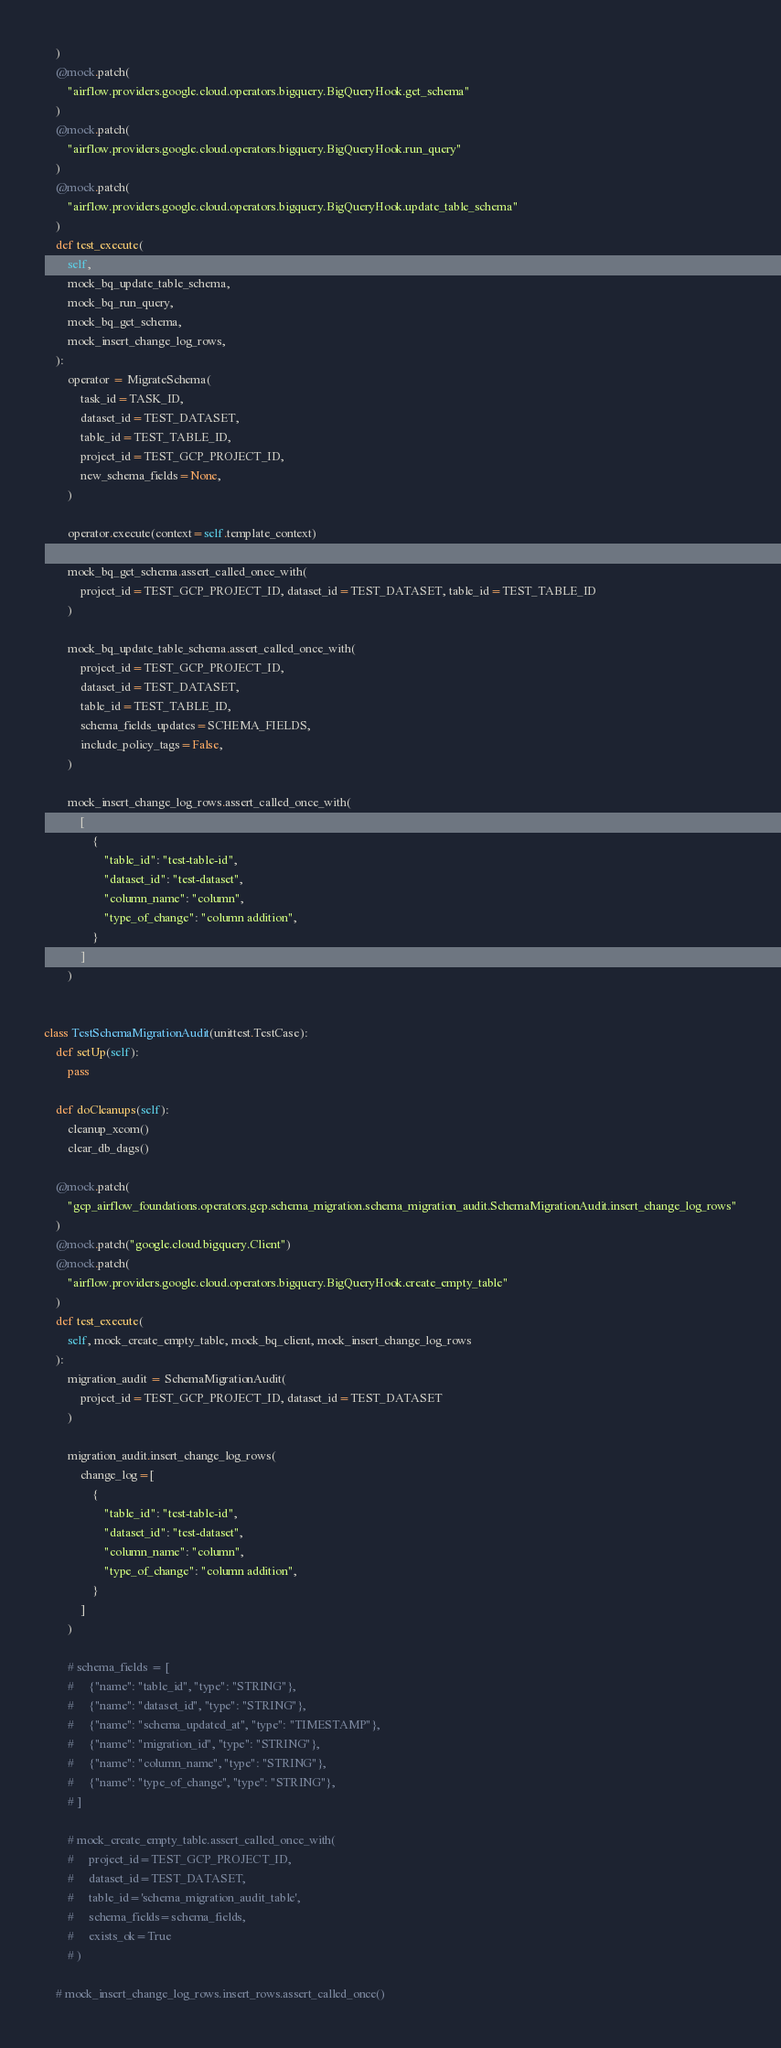<code> <loc_0><loc_0><loc_500><loc_500><_Python_>    )
    @mock.patch(
        "airflow.providers.google.cloud.operators.bigquery.BigQueryHook.get_schema"
    )
    @mock.patch(
        "airflow.providers.google.cloud.operators.bigquery.BigQueryHook.run_query"
    )
    @mock.patch(
        "airflow.providers.google.cloud.operators.bigquery.BigQueryHook.update_table_schema"
    )
    def test_execute(
        self,
        mock_bq_update_table_schema,
        mock_bq_run_query,
        mock_bq_get_schema,
        mock_insert_change_log_rows,
    ):
        operator = MigrateSchema(
            task_id=TASK_ID,
            dataset_id=TEST_DATASET,
            table_id=TEST_TABLE_ID,
            project_id=TEST_GCP_PROJECT_ID,
            new_schema_fields=None,
        )

        operator.execute(context=self.template_context)

        mock_bq_get_schema.assert_called_once_with(
            project_id=TEST_GCP_PROJECT_ID, dataset_id=TEST_DATASET, table_id=TEST_TABLE_ID
        )

        mock_bq_update_table_schema.assert_called_once_with(
            project_id=TEST_GCP_PROJECT_ID,
            dataset_id=TEST_DATASET,
            table_id=TEST_TABLE_ID,
            schema_fields_updates=SCHEMA_FIELDS,
            include_policy_tags=False,
        )

        mock_insert_change_log_rows.assert_called_once_with(
            [
                {
                    "table_id": "test-table-id",
                    "dataset_id": "test-dataset",
                    "column_name": "column",
                    "type_of_change": "column addition",
                }
            ]
        )


class TestSchemaMigrationAudit(unittest.TestCase):
    def setUp(self):
        pass

    def doCleanups(self):
        cleanup_xcom()
        clear_db_dags()

    @mock.patch(
        "gcp_airflow_foundations.operators.gcp.schema_migration.schema_migration_audit.SchemaMigrationAudit.insert_change_log_rows"
    )
    @mock.patch("google.cloud.bigquery.Client")
    @mock.patch(
        "airflow.providers.google.cloud.operators.bigquery.BigQueryHook.create_empty_table"
    )
    def test_execute(
        self, mock_create_empty_table, mock_bq_client, mock_insert_change_log_rows
    ):
        migration_audit = SchemaMigrationAudit(
            project_id=TEST_GCP_PROJECT_ID, dataset_id=TEST_DATASET
        )

        migration_audit.insert_change_log_rows(
            change_log=[
                {
                    "table_id": "test-table-id",
                    "dataset_id": "test-dataset",
                    "column_name": "column",
                    "type_of_change": "column addition",
                }
            ]
        )

        # schema_fields = [
        #     {"name": "table_id", "type": "STRING"},
        #     {"name": "dataset_id", "type": "STRING"},
        #     {"name": "schema_updated_at", "type": "TIMESTAMP"},
        #     {"name": "migration_id", "type": "STRING"},
        #     {"name": "column_name", "type": "STRING"},
        #     {"name": "type_of_change", "type": "STRING"},
        # ]

        # mock_create_empty_table.assert_called_once_with(
        #     project_id=TEST_GCP_PROJECT_ID,
        #     dataset_id=TEST_DATASET,
        #     table_id='schema_migration_audit_table',
        #     schema_fields=schema_fields,
        #     exists_ok=True
        # )

    # mock_insert_change_log_rows.insert_rows.assert_called_once()
</code> 